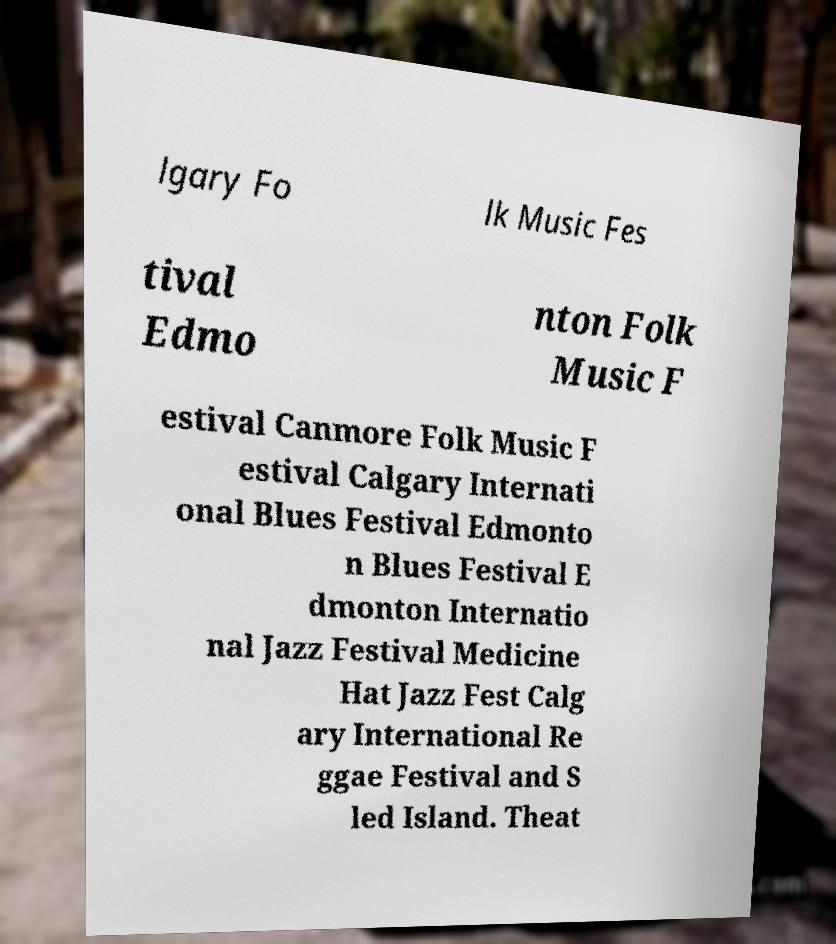Could you assist in decoding the text presented in this image and type it out clearly? lgary Fo lk Music Fes tival Edmo nton Folk Music F estival Canmore Folk Music F estival Calgary Internati onal Blues Festival Edmonto n Blues Festival E dmonton Internatio nal Jazz Festival Medicine Hat Jazz Fest Calg ary International Re ggae Festival and S led Island. Theat 